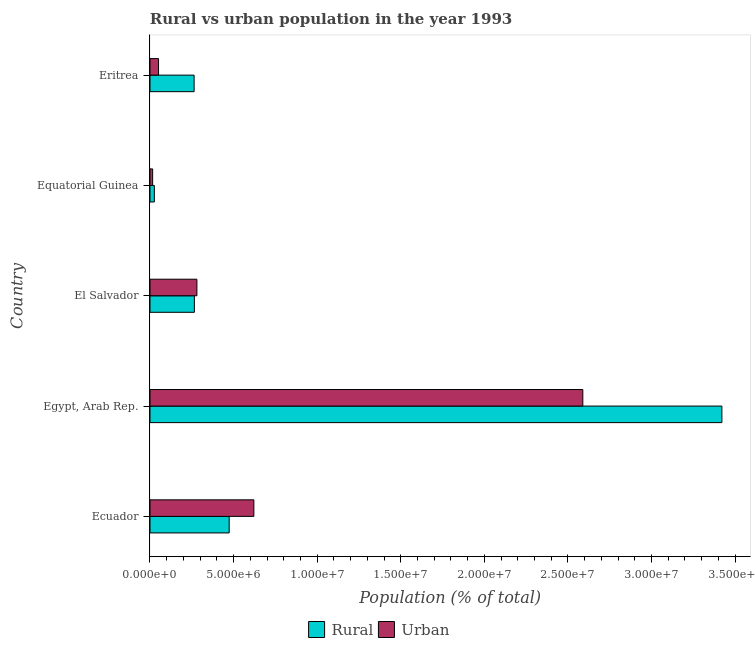How many different coloured bars are there?
Give a very brief answer. 2. Are the number of bars on each tick of the Y-axis equal?
Offer a terse response. Yes. What is the label of the 3rd group of bars from the top?
Provide a short and direct response. El Salvador. In how many cases, is the number of bars for a given country not equal to the number of legend labels?
Make the answer very short. 0. What is the rural population density in Egypt, Arab Rep.?
Provide a short and direct response. 3.42e+07. Across all countries, what is the maximum urban population density?
Provide a short and direct response. 2.59e+07. Across all countries, what is the minimum urban population density?
Give a very brief answer. 1.58e+05. In which country was the rural population density maximum?
Offer a very short reply. Egypt, Arab Rep. In which country was the rural population density minimum?
Keep it short and to the point. Equatorial Guinea. What is the total rural population density in the graph?
Your response must be concise. 4.45e+07. What is the difference between the rural population density in El Salvador and that in Eritrea?
Your answer should be very brief. 1.54e+04. What is the difference between the rural population density in Ecuador and the urban population density in Equatorial Guinea?
Offer a very short reply. 4.58e+06. What is the average rural population density per country?
Give a very brief answer. 8.90e+06. What is the difference between the rural population density and urban population density in Eritrea?
Your response must be concise. 2.13e+06. What is the ratio of the urban population density in Egypt, Arab Rep. to that in Equatorial Guinea?
Make the answer very short. 163.76. Is the difference between the urban population density in Ecuador and El Salvador greater than the difference between the rural population density in Ecuador and El Salvador?
Keep it short and to the point. Yes. What is the difference between the highest and the second highest rural population density?
Offer a very short reply. 2.95e+07. What is the difference between the highest and the lowest rural population density?
Your response must be concise. 3.40e+07. What does the 2nd bar from the top in Egypt, Arab Rep. represents?
Make the answer very short. Rural. What does the 1st bar from the bottom in Egypt, Arab Rep. represents?
Your answer should be compact. Rural. How many bars are there?
Provide a succinct answer. 10. Where does the legend appear in the graph?
Offer a terse response. Bottom center. What is the title of the graph?
Keep it short and to the point. Rural vs urban population in the year 1993. Does "Methane emissions" appear as one of the legend labels in the graph?
Your response must be concise. No. What is the label or title of the X-axis?
Give a very brief answer. Population (% of total). What is the label or title of the Y-axis?
Ensure brevity in your answer.  Country. What is the Population (% of total) of Rural in Ecuador?
Provide a short and direct response. 4.74e+06. What is the Population (% of total) in Urban in Ecuador?
Your answer should be compact. 6.21e+06. What is the Population (% of total) in Rural in Egypt, Arab Rep.?
Make the answer very short. 3.42e+07. What is the Population (% of total) in Urban in Egypt, Arab Rep.?
Ensure brevity in your answer.  2.59e+07. What is the Population (% of total) in Rural in El Salvador?
Your answer should be very brief. 2.66e+06. What is the Population (% of total) in Urban in El Salvador?
Provide a short and direct response. 2.81e+06. What is the Population (% of total) of Rural in Equatorial Guinea?
Your response must be concise. 2.60e+05. What is the Population (% of total) in Urban in Equatorial Guinea?
Make the answer very short. 1.58e+05. What is the Population (% of total) of Rural in Eritrea?
Give a very brief answer. 2.64e+06. What is the Population (% of total) in Urban in Eritrea?
Your answer should be very brief. 5.11e+05. Across all countries, what is the maximum Population (% of total) in Rural?
Your response must be concise. 3.42e+07. Across all countries, what is the maximum Population (% of total) of Urban?
Make the answer very short. 2.59e+07. Across all countries, what is the minimum Population (% of total) of Rural?
Give a very brief answer. 2.60e+05. Across all countries, what is the minimum Population (% of total) in Urban?
Give a very brief answer. 1.58e+05. What is the total Population (% of total) of Rural in the graph?
Keep it short and to the point. 4.45e+07. What is the total Population (% of total) in Urban in the graph?
Your answer should be compact. 3.56e+07. What is the difference between the Population (% of total) of Rural in Ecuador and that in Egypt, Arab Rep.?
Provide a short and direct response. -2.95e+07. What is the difference between the Population (% of total) in Urban in Ecuador and that in Egypt, Arab Rep.?
Your response must be concise. -1.97e+07. What is the difference between the Population (% of total) in Rural in Ecuador and that in El Salvador?
Make the answer very short. 2.08e+06. What is the difference between the Population (% of total) of Urban in Ecuador and that in El Salvador?
Offer a terse response. 3.41e+06. What is the difference between the Population (% of total) in Rural in Ecuador and that in Equatorial Guinea?
Give a very brief answer. 4.48e+06. What is the difference between the Population (% of total) in Urban in Ecuador and that in Equatorial Guinea?
Your answer should be compact. 6.06e+06. What is the difference between the Population (% of total) of Rural in Ecuador and that in Eritrea?
Give a very brief answer. 2.10e+06. What is the difference between the Population (% of total) of Urban in Ecuador and that in Eritrea?
Provide a short and direct response. 5.70e+06. What is the difference between the Population (% of total) in Rural in Egypt, Arab Rep. and that in El Salvador?
Give a very brief answer. 3.16e+07. What is the difference between the Population (% of total) in Urban in Egypt, Arab Rep. and that in El Salvador?
Give a very brief answer. 2.31e+07. What is the difference between the Population (% of total) in Rural in Egypt, Arab Rep. and that in Equatorial Guinea?
Offer a terse response. 3.40e+07. What is the difference between the Population (% of total) in Urban in Egypt, Arab Rep. and that in Equatorial Guinea?
Give a very brief answer. 2.57e+07. What is the difference between the Population (% of total) in Rural in Egypt, Arab Rep. and that in Eritrea?
Your answer should be compact. 3.16e+07. What is the difference between the Population (% of total) in Urban in Egypt, Arab Rep. and that in Eritrea?
Offer a terse response. 2.54e+07. What is the difference between the Population (% of total) of Rural in El Salvador and that in Equatorial Guinea?
Your response must be concise. 2.40e+06. What is the difference between the Population (% of total) in Urban in El Salvador and that in Equatorial Guinea?
Provide a succinct answer. 2.65e+06. What is the difference between the Population (% of total) in Rural in El Salvador and that in Eritrea?
Ensure brevity in your answer.  1.54e+04. What is the difference between the Population (% of total) of Urban in El Salvador and that in Eritrea?
Provide a short and direct response. 2.30e+06. What is the difference between the Population (% of total) of Rural in Equatorial Guinea and that in Eritrea?
Make the answer very short. -2.38e+06. What is the difference between the Population (% of total) of Urban in Equatorial Guinea and that in Eritrea?
Give a very brief answer. -3.53e+05. What is the difference between the Population (% of total) in Rural in Ecuador and the Population (% of total) in Urban in Egypt, Arab Rep.?
Keep it short and to the point. -2.12e+07. What is the difference between the Population (% of total) of Rural in Ecuador and the Population (% of total) of Urban in El Salvador?
Keep it short and to the point. 1.93e+06. What is the difference between the Population (% of total) in Rural in Ecuador and the Population (% of total) in Urban in Equatorial Guinea?
Offer a very short reply. 4.58e+06. What is the difference between the Population (% of total) in Rural in Ecuador and the Population (% of total) in Urban in Eritrea?
Provide a short and direct response. 4.23e+06. What is the difference between the Population (% of total) in Rural in Egypt, Arab Rep. and the Population (% of total) in Urban in El Salvador?
Provide a succinct answer. 3.14e+07. What is the difference between the Population (% of total) in Rural in Egypt, Arab Rep. and the Population (% of total) in Urban in Equatorial Guinea?
Your response must be concise. 3.41e+07. What is the difference between the Population (% of total) in Rural in Egypt, Arab Rep. and the Population (% of total) in Urban in Eritrea?
Provide a succinct answer. 3.37e+07. What is the difference between the Population (% of total) in Rural in El Salvador and the Population (% of total) in Urban in Equatorial Guinea?
Keep it short and to the point. 2.50e+06. What is the difference between the Population (% of total) of Rural in El Salvador and the Population (% of total) of Urban in Eritrea?
Provide a short and direct response. 2.14e+06. What is the difference between the Population (% of total) in Rural in Equatorial Guinea and the Population (% of total) in Urban in Eritrea?
Provide a short and direct response. -2.50e+05. What is the average Population (% of total) of Rural per country?
Your answer should be compact. 8.90e+06. What is the average Population (% of total) in Urban per country?
Provide a short and direct response. 7.12e+06. What is the difference between the Population (% of total) in Rural and Population (% of total) in Urban in Ecuador?
Provide a short and direct response. -1.48e+06. What is the difference between the Population (% of total) of Rural and Population (% of total) of Urban in Egypt, Arab Rep.?
Make the answer very short. 8.32e+06. What is the difference between the Population (% of total) of Rural and Population (% of total) of Urban in El Salvador?
Your answer should be very brief. -1.51e+05. What is the difference between the Population (% of total) of Rural and Population (% of total) of Urban in Equatorial Guinea?
Make the answer very short. 1.02e+05. What is the difference between the Population (% of total) of Rural and Population (% of total) of Urban in Eritrea?
Make the answer very short. 2.13e+06. What is the ratio of the Population (% of total) in Rural in Ecuador to that in Egypt, Arab Rep.?
Your answer should be compact. 0.14. What is the ratio of the Population (% of total) of Urban in Ecuador to that in Egypt, Arab Rep.?
Provide a succinct answer. 0.24. What is the ratio of the Population (% of total) in Rural in Ecuador to that in El Salvador?
Your answer should be compact. 1.78. What is the ratio of the Population (% of total) in Urban in Ecuador to that in El Salvador?
Offer a terse response. 2.21. What is the ratio of the Population (% of total) of Rural in Ecuador to that in Equatorial Guinea?
Your answer should be compact. 18.2. What is the ratio of the Population (% of total) of Urban in Ecuador to that in Equatorial Guinea?
Make the answer very short. 39.3. What is the ratio of the Population (% of total) of Rural in Ecuador to that in Eritrea?
Your response must be concise. 1.79. What is the ratio of the Population (% of total) of Urban in Ecuador to that in Eritrea?
Your answer should be compact. 12.17. What is the ratio of the Population (% of total) of Rural in Egypt, Arab Rep. to that in El Salvador?
Provide a succinct answer. 12.88. What is the ratio of the Population (% of total) of Urban in Egypt, Arab Rep. to that in El Salvador?
Your response must be concise. 9.23. What is the ratio of the Population (% of total) in Rural in Egypt, Arab Rep. to that in Equatorial Guinea?
Provide a short and direct response. 131.45. What is the ratio of the Population (% of total) of Urban in Egypt, Arab Rep. to that in Equatorial Guinea?
Make the answer very short. 163.76. What is the ratio of the Population (% of total) in Rural in Egypt, Arab Rep. to that in Eritrea?
Offer a terse response. 12.96. What is the ratio of the Population (% of total) of Urban in Egypt, Arab Rep. to that in Eritrea?
Your answer should be very brief. 50.7. What is the ratio of the Population (% of total) in Rural in El Salvador to that in Equatorial Guinea?
Your answer should be compact. 10.2. What is the ratio of the Population (% of total) of Urban in El Salvador to that in Equatorial Guinea?
Make the answer very short. 17.75. What is the ratio of the Population (% of total) of Urban in El Salvador to that in Eritrea?
Ensure brevity in your answer.  5.49. What is the ratio of the Population (% of total) in Rural in Equatorial Guinea to that in Eritrea?
Offer a very short reply. 0.1. What is the ratio of the Population (% of total) of Urban in Equatorial Guinea to that in Eritrea?
Your answer should be very brief. 0.31. What is the difference between the highest and the second highest Population (% of total) of Rural?
Keep it short and to the point. 2.95e+07. What is the difference between the highest and the second highest Population (% of total) in Urban?
Give a very brief answer. 1.97e+07. What is the difference between the highest and the lowest Population (% of total) of Rural?
Your response must be concise. 3.40e+07. What is the difference between the highest and the lowest Population (% of total) of Urban?
Provide a short and direct response. 2.57e+07. 